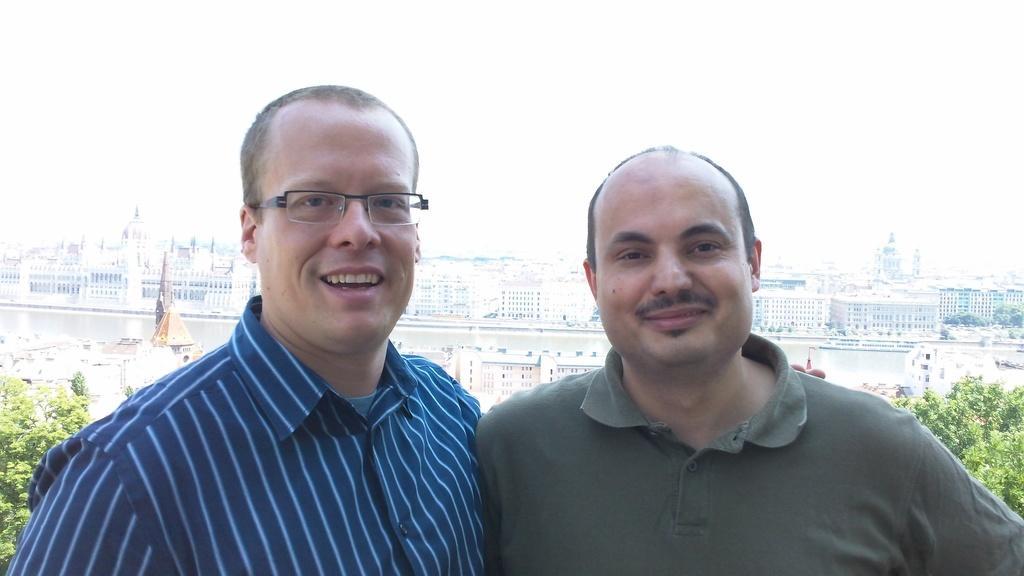Please provide a concise description of this image. In this image we can see this person wearing shirt and spectacles and this person wearing T-shirt are smiling. In the background, we can see trees, buildings, water and the sky. 